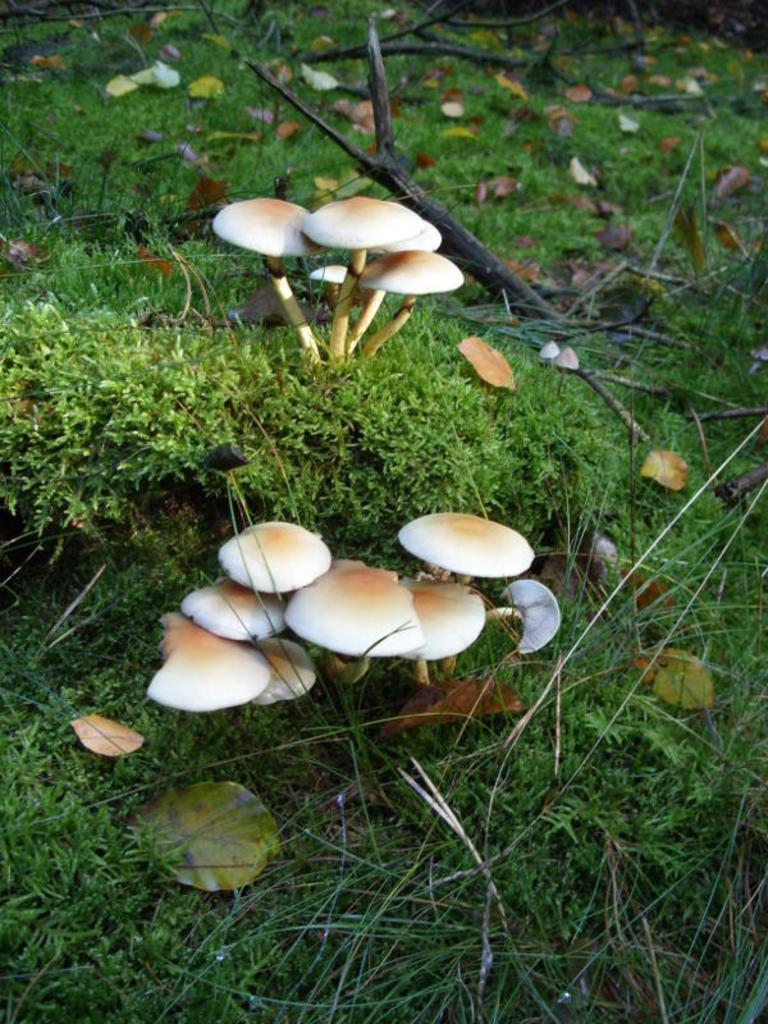What type of fungi can be seen in the image? There are mushrooms in the image. What colors are the mushrooms? The mushrooms are in white and cream color. What can be seen in the background of the image? There are plants and grass in the background of the image. What color are the plants and grass? The plants are green in color, and so is the grass. Where is the crate of cherries located in the image? There is no crate of cherries present in the image. What type of flame can be seen in the image? There is no flame present in the image. 